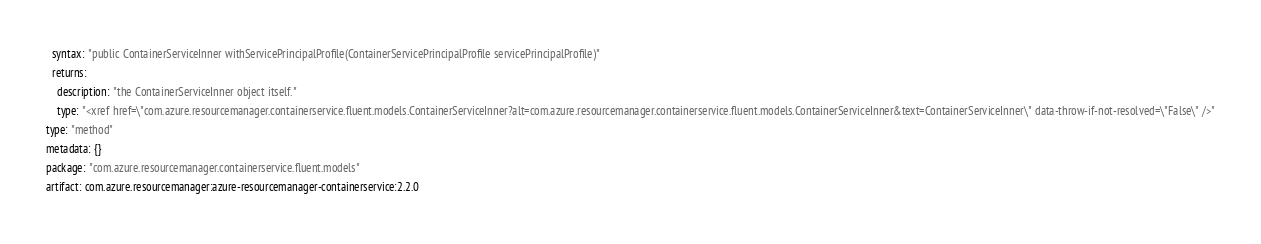Convert code to text. <code><loc_0><loc_0><loc_500><loc_500><_YAML_>  syntax: "public ContainerServiceInner withServicePrincipalProfile(ContainerServicePrincipalProfile servicePrincipalProfile)"
  returns:
    description: "the ContainerServiceInner object itself."
    type: "<xref href=\"com.azure.resourcemanager.containerservice.fluent.models.ContainerServiceInner?alt=com.azure.resourcemanager.containerservice.fluent.models.ContainerServiceInner&text=ContainerServiceInner\" data-throw-if-not-resolved=\"False\" />"
type: "method"
metadata: {}
package: "com.azure.resourcemanager.containerservice.fluent.models"
artifact: com.azure.resourcemanager:azure-resourcemanager-containerservice:2.2.0
</code> 